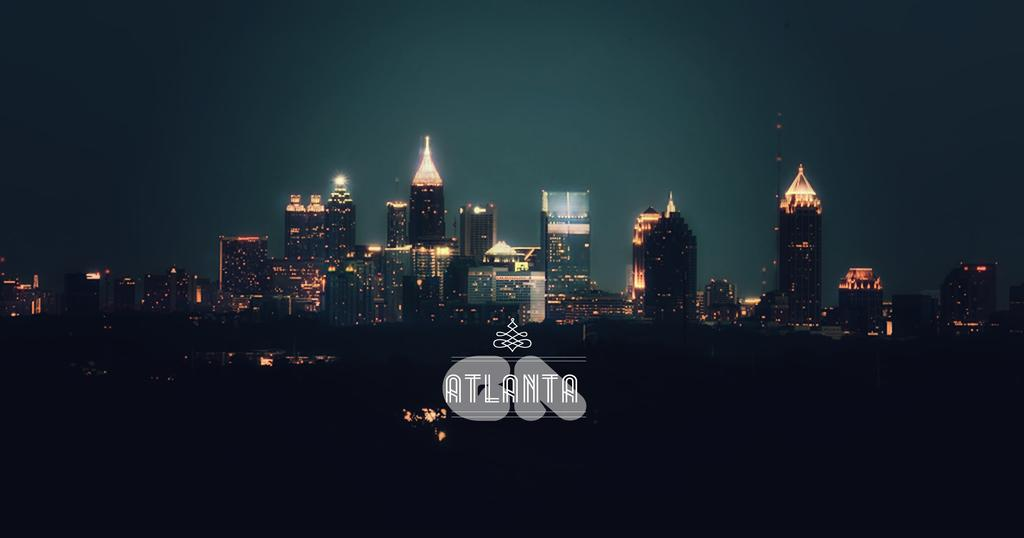<image>
Provide a brief description of the given image. The Atlanta, Georgia city skyline at night with the buildings lit up. 